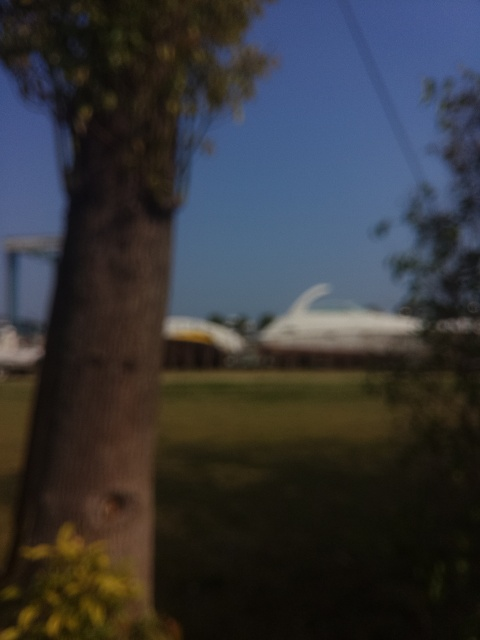What elements can you identify in the image despite the haze, and what does this reveal about the setting? Despite the haze, one can make out the existence of foliage and a bright sky, suggesting an outdoor setting during the daytime. The impression of open space and possibly structures in the distance hints at a recreational or park area where people might gather for leisure or travel. 